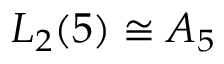<formula> <loc_0><loc_0><loc_500><loc_500>L _ { 2 } ( 5 ) \cong A _ { 5 }</formula> 